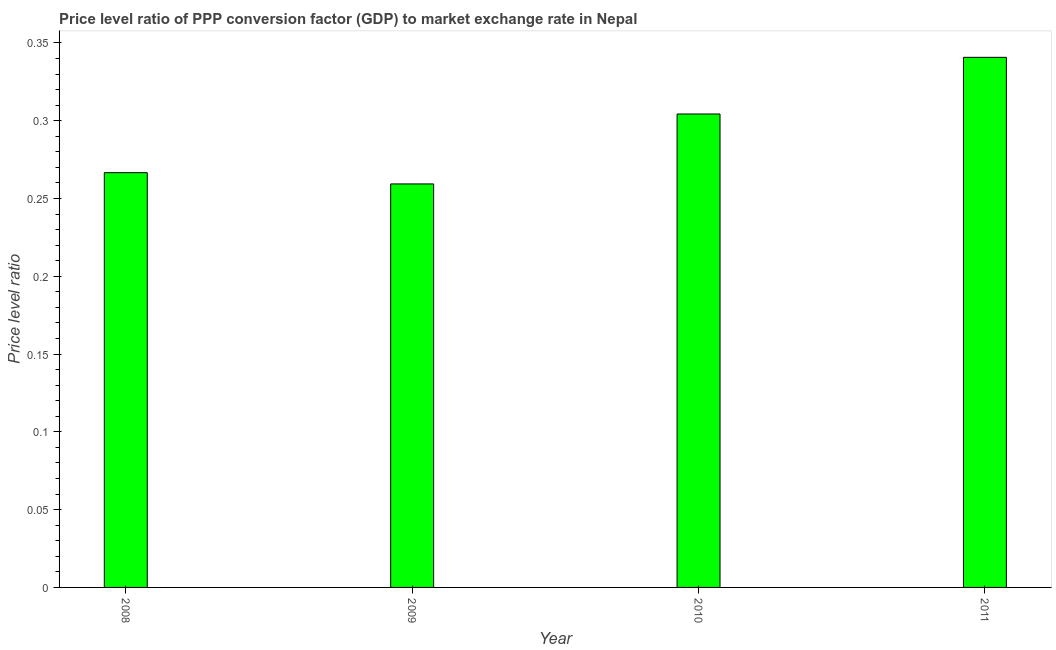Does the graph contain any zero values?
Your response must be concise. No. Does the graph contain grids?
Offer a terse response. No. What is the title of the graph?
Keep it short and to the point. Price level ratio of PPP conversion factor (GDP) to market exchange rate in Nepal. What is the label or title of the X-axis?
Provide a short and direct response. Year. What is the label or title of the Y-axis?
Your answer should be compact. Price level ratio. What is the price level ratio in 2008?
Offer a terse response. 0.27. Across all years, what is the maximum price level ratio?
Your answer should be very brief. 0.34. Across all years, what is the minimum price level ratio?
Provide a succinct answer. 0.26. In which year was the price level ratio maximum?
Provide a succinct answer. 2011. In which year was the price level ratio minimum?
Your response must be concise. 2009. What is the sum of the price level ratio?
Provide a short and direct response. 1.17. What is the difference between the price level ratio in 2009 and 2011?
Your answer should be very brief. -0.08. What is the average price level ratio per year?
Keep it short and to the point. 0.29. What is the median price level ratio?
Offer a very short reply. 0.29. In how many years, is the price level ratio greater than 0.01 ?
Your response must be concise. 4. What is the ratio of the price level ratio in 2009 to that in 2010?
Provide a succinct answer. 0.85. Is the price level ratio in 2009 less than that in 2010?
Provide a succinct answer. Yes. Is the difference between the price level ratio in 2009 and 2010 greater than the difference between any two years?
Your response must be concise. No. What is the difference between the highest and the second highest price level ratio?
Ensure brevity in your answer.  0.04. What is the difference between the highest and the lowest price level ratio?
Your answer should be compact. 0.08. Are all the bars in the graph horizontal?
Your answer should be very brief. No. Are the values on the major ticks of Y-axis written in scientific E-notation?
Offer a terse response. No. What is the Price level ratio in 2008?
Offer a very short reply. 0.27. What is the Price level ratio of 2009?
Give a very brief answer. 0.26. What is the Price level ratio of 2010?
Keep it short and to the point. 0.3. What is the Price level ratio of 2011?
Your response must be concise. 0.34. What is the difference between the Price level ratio in 2008 and 2009?
Ensure brevity in your answer.  0.01. What is the difference between the Price level ratio in 2008 and 2010?
Offer a terse response. -0.04. What is the difference between the Price level ratio in 2008 and 2011?
Your answer should be very brief. -0.07. What is the difference between the Price level ratio in 2009 and 2010?
Your answer should be very brief. -0.04. What is the difference between the Price level ratio in 2009 and 2011?
Make the answer very short. -0.08. What is the difference between the Price level ratio in 2010 and 2011?
Your answer should be very brief. -0.04. What is the ratio of the Price level ratio in 2008 to that in 2009?
Your response must be concise. 1.03. What is the ratio of the Price level ratio in 2008 to that in 2010?
Your answer should be compact. 0.88. What is the ratio of the Price level ratio in 2008 to that in 2011?
Provide a succinct answer. 0.78. What is the ratio of the Price level ratio in 2009 to that in 2010?
Keep it short and to the point. 0.85. What is the ratio of the Price level ratio in 2009 to that in 2011?
Offer a terse response. 0.76. What is the ratio of the Price level ratio in 2010 to that in 2011?
Ensure brevity in your answer.  0.89. 